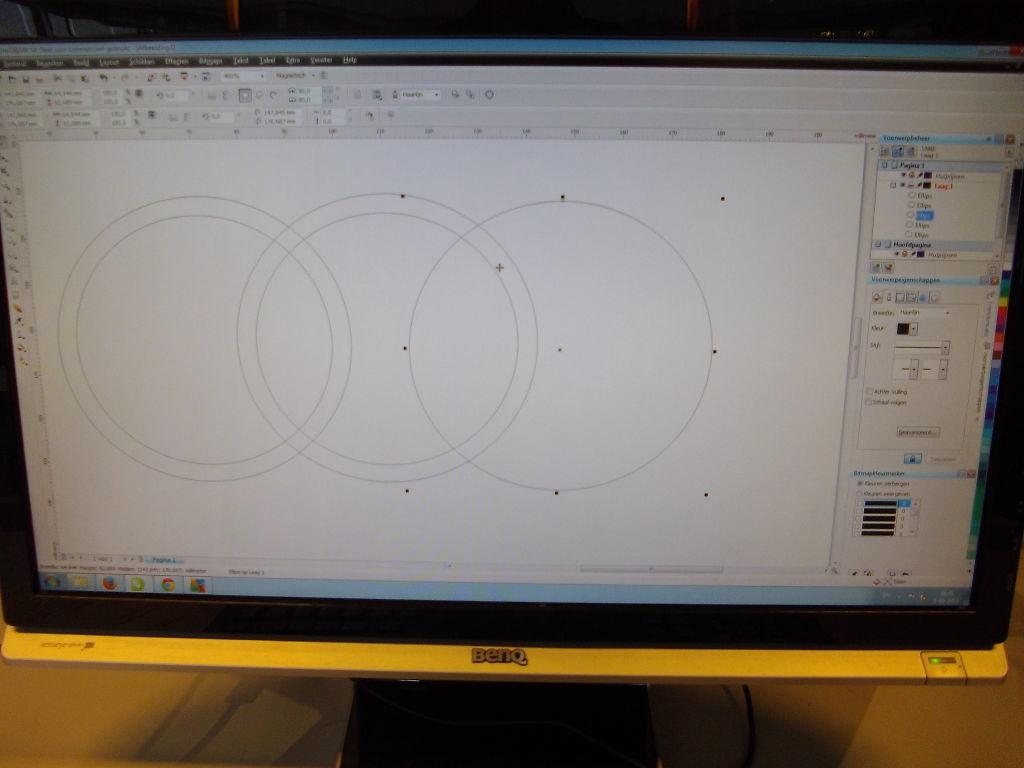<image>
Present a compact description of the photo's key features. A Benq computer is open and has a program loaded that is showing drawings of circles. 